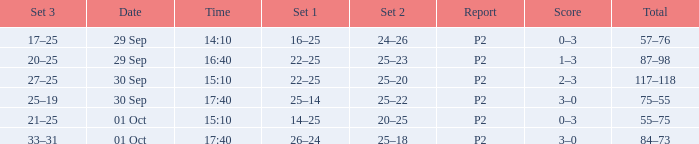What Score has a time of 14:10? 0–3. 